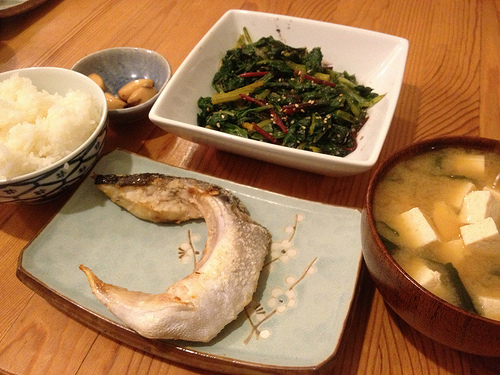<image>
Is there a bowl in front of the rice? No. The bowl is not in front of the rice. The spatial positioning shows a different relationship between these objects. 